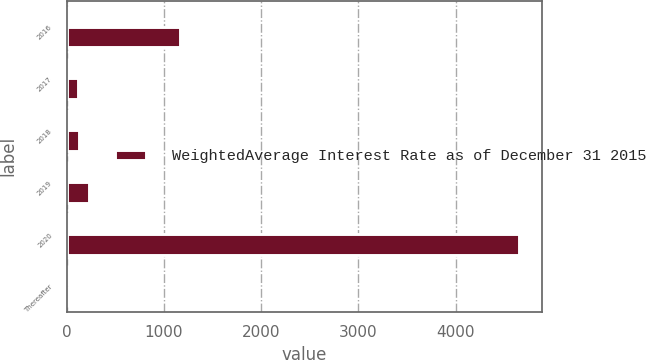Convert chart to OTSL. <chart><loc_0><loc_0><loc_500><loc_500><stacked_bar_chart><ecel><fcel>2016<fcel>2017<fcel>2018<fcel>2019<fcel>2020<fcel>Thereafter<nl><fcel>nan<fcel>2.87<fcel>3.45<fcel>2.79<fcel>3.05<fcel>3.77<fcel>4.78<nl><fcel>WeightedAverage Interest Rate as of December 31 2015<fcel>1163<fcel>120<fcel>127<fcel>226<fcel>4657<fcel>4.78<nl></chart> 